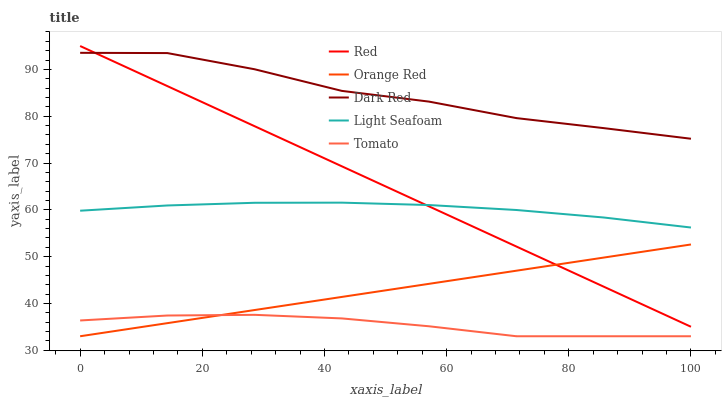Does Tomato have the minimum area under the curve?
Answer yes or no. Yes. Does Dark Red have the maximum area under the curve?
Answer yes or no. Yes. Does Light Seafoam have the minimum area under the curve?
Answer yes or no. No. Does Light Seafoam have the maximum area under the curve?
Answer yes or no. No. Is Red the smoothest?
Answer yes or no. Yes. Is Dark Red the roughest?
Answer yes or no. Yes. Is Light Seafoam the smoothest?
Answer yes or no. No. Is Light Seafoam the roughest?
Answer yes or no. No. Does Light Seafoam have the lowest value?
Answer yes or no. No. Does Dark Red have the highest value?
Answer yes or no. No. Is Tomato less than Dark Red?
Answer yes or no. Yes. Is Red greater than Tomato?
Answer yes or no. Yes. Does Tomato intersect Dark Red?
Answer yes or no. No. 